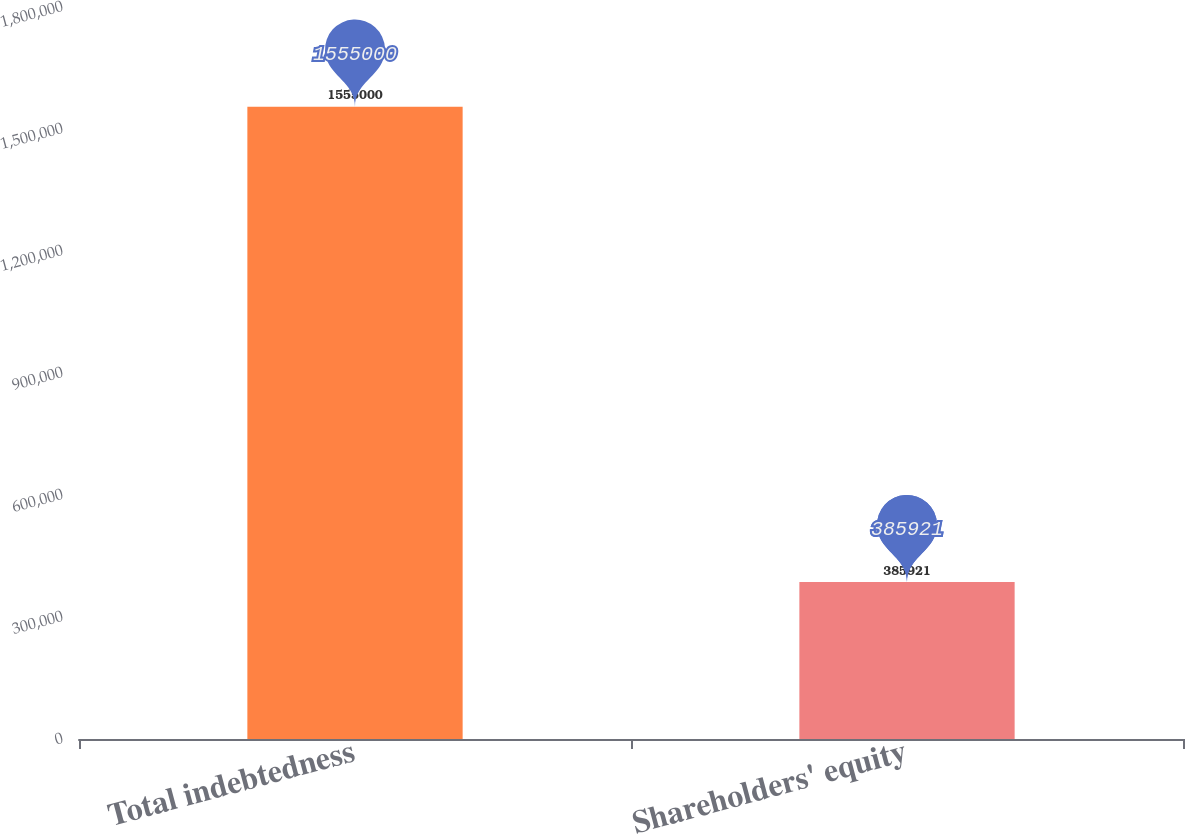Convert chart to OTSL. <chart><loc_0><loc_0><loc_500><loc_500><bar_chart><fcel>Total indebtedness<fcel>Shareholders' equity<nl><fcel>1.555e+06<fcel>385921<nl></chart> 